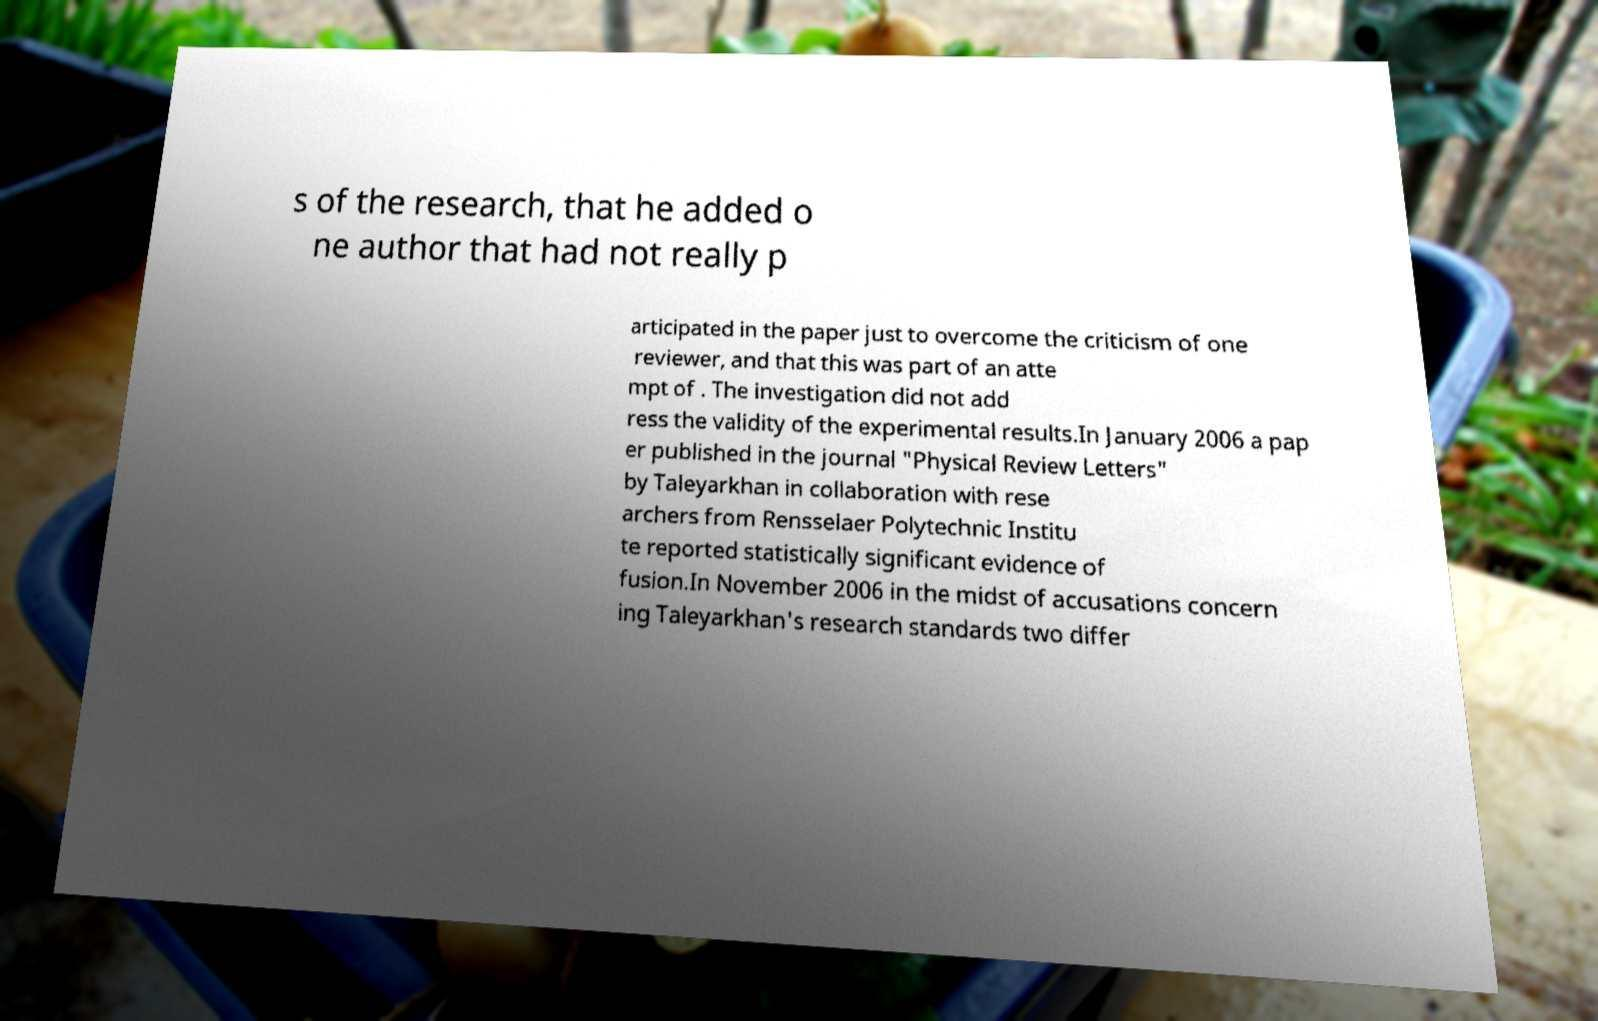What messages or text are displayed in this image? I need them in a readable, typed format. s of the research, that he added o ne author that had not really p articipated in the paper just to overcome the criticism of one reviewer, and that this was part of an atte mpt of . The investigation did not add ress the validity of the experimental results.In January 2006 a pap er published in the journal "Physical Review Letters" by Taleyarkhan in collaboration with rese archers from Rensselaer Polytechnic Institu te reported statistically significant evidence of fusion.In November 2006 in the midst of accusations concern ing Taleyarkhan's research standards two differ 